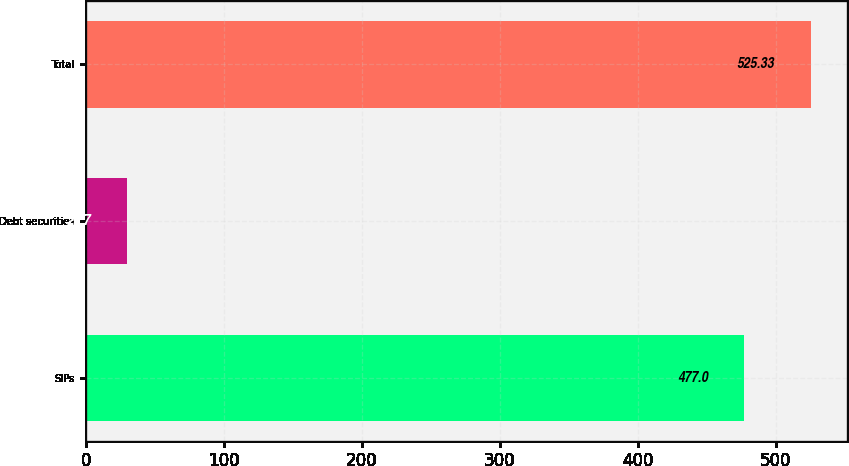Convert chart. <chart><loc_0><loc_0><loc_500><loc_500><bar_chart><fcel>SIPs<fcel>Debt securities<fcel>Total<nl><fcel>477<fcel>29.7<fcel>525.33<nl></chart> 